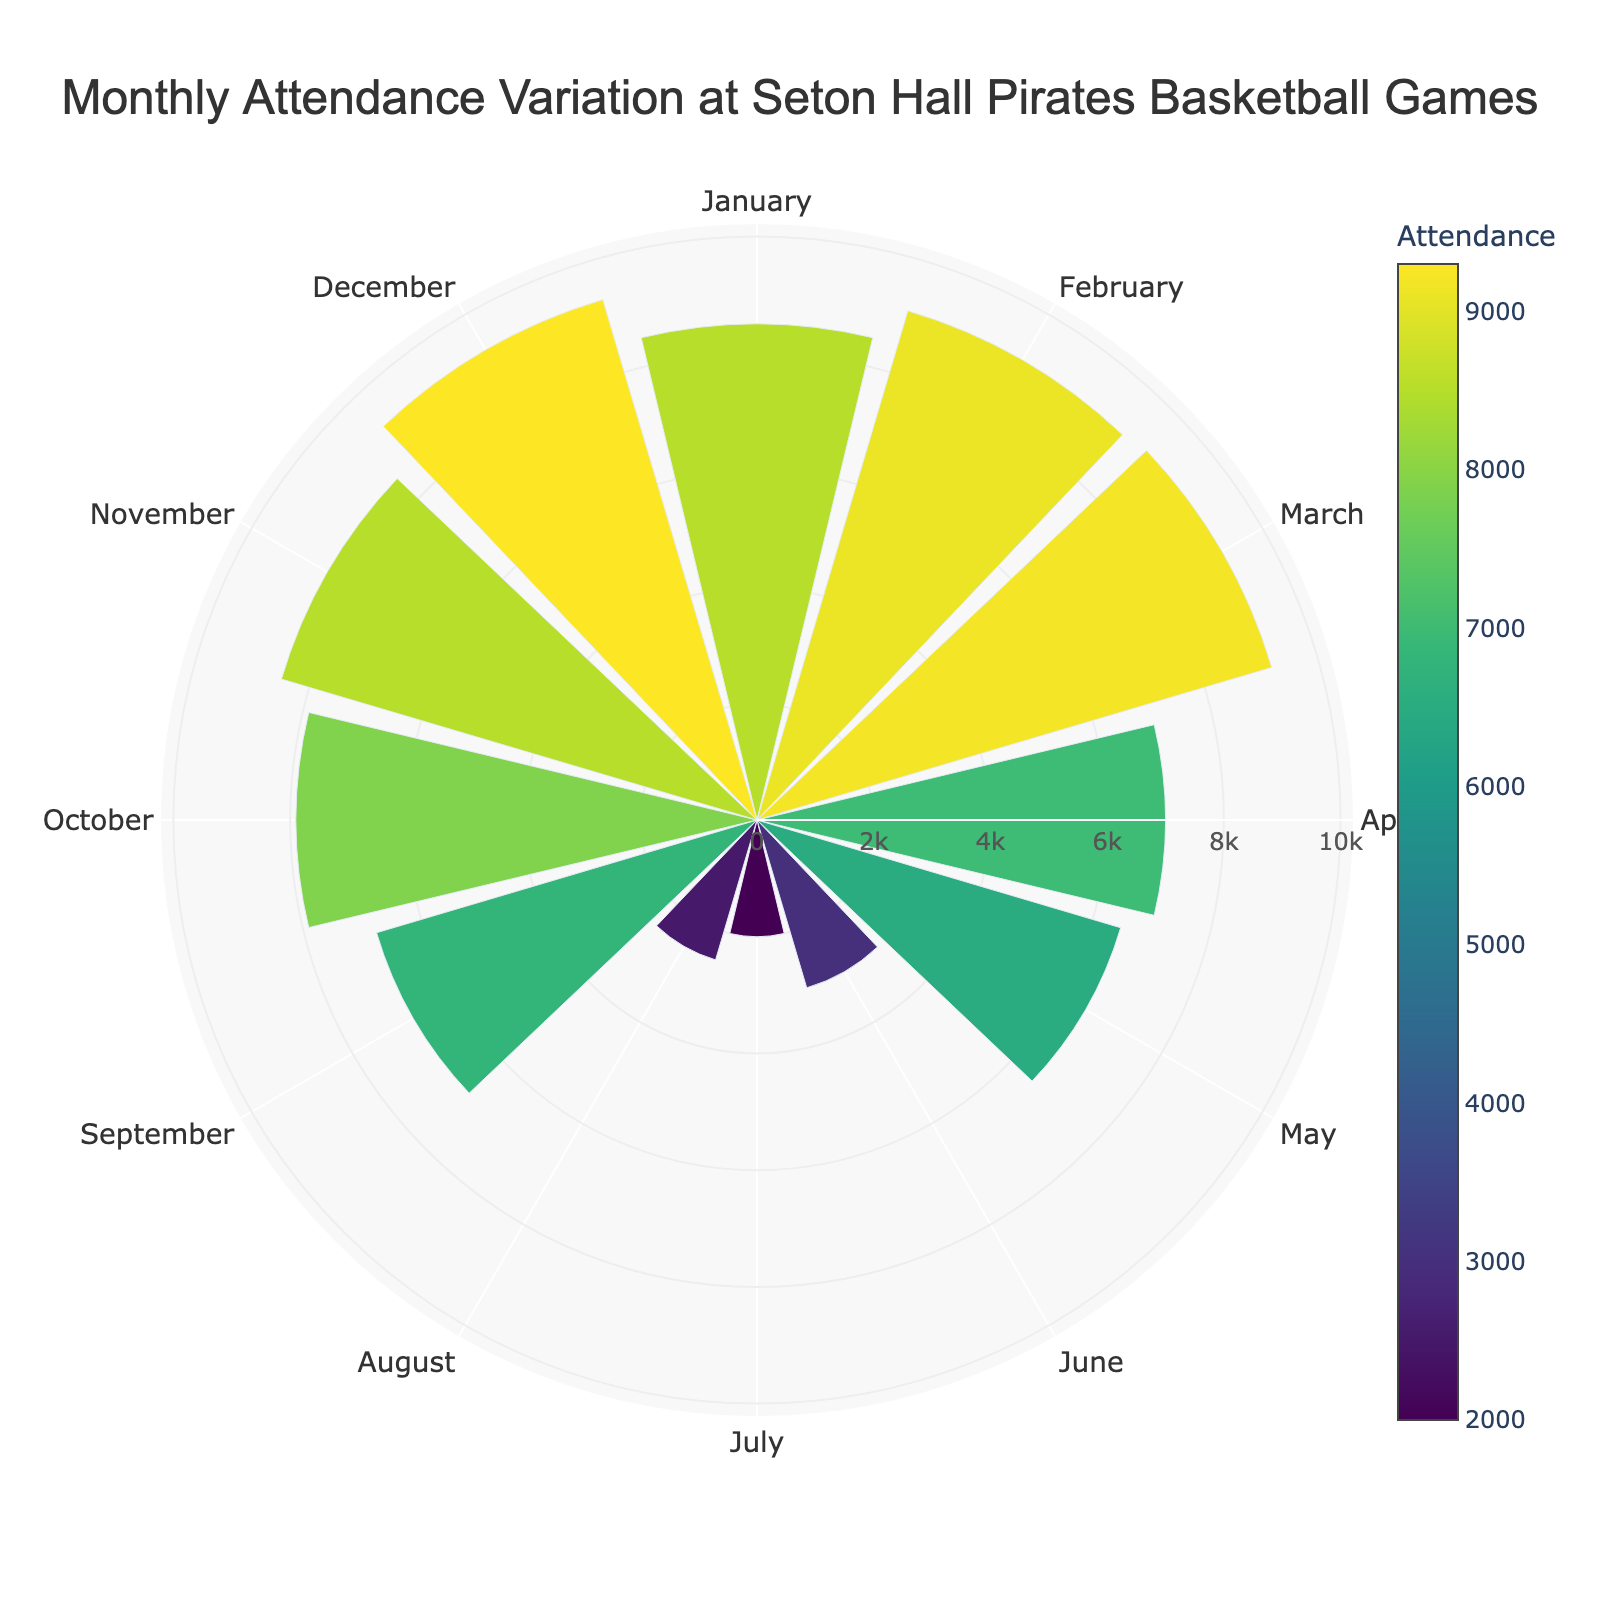What's the highest monthly attendance? Look at the radial bars to find the longest one. The month with the highest attendance is labeled and its attendance value is shown in a hover tooltip.
Answer: 9300 What's the title of the chart? The title is typically found at the top of the chart.
Answer: Monthly Attendance Variation at Seton Hall Pirates Basketball Games Which month has the lowest attendance? Locate the smallest radial bar on the polar chart. The month and its attendance value are visible in a tooltip when hovered over.
Answer: July What's the total attendance for the first quarter (January, February, March)? Sum the attendance values for January, February, and March (8500 + 9100 + 9200).
Answer: 26800 How does the attendance in October compare to November? Look at and compare the lengths of the radial bars for October and November.
Answer: November is higher What's the average attendance for May to August? Sum the attendance values for May, June, July, and August (6500 + 3000 + 2000 + 2500) and divide by 4. (6500 + 3000 + 2000 + 2500) / 4 = 14000 / 4 = 3500
Answer: 3500 Which month shows an attendance just slightly below 8000? Check the radial bars for the month closest to but below 8000 attendance. October is slightly below 8000 with an attendance of 7900.
Answer: October By how much does the attendance in December exceed that of April? Subtract April's attendance from December's attendance (9300 - 7000).
Answer: 2300 What's the median monthly attendance? Arrange the attendance values in ascending order and find the middle value. The middle values (because there are 12 data points) are for June (3000), July (2000), August (2500), September (6800), October (7900), November (8500), and January (8500). The median value is the average of June (3000) and July (2000).
Answer: 7650 Is there a general trend in attendance changes throughout the year? Look for patterns in the lengths of the bars throughout the months in the chart. Attendance is lower in the summer months and higher during the basketball season.
Answer: Higher in winter, lower in summer 